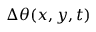Convert formula to latex. <formula><loc_0><loc_0><loc_500><loc_500>\Delta \theta ( x , y , t )</formula> 